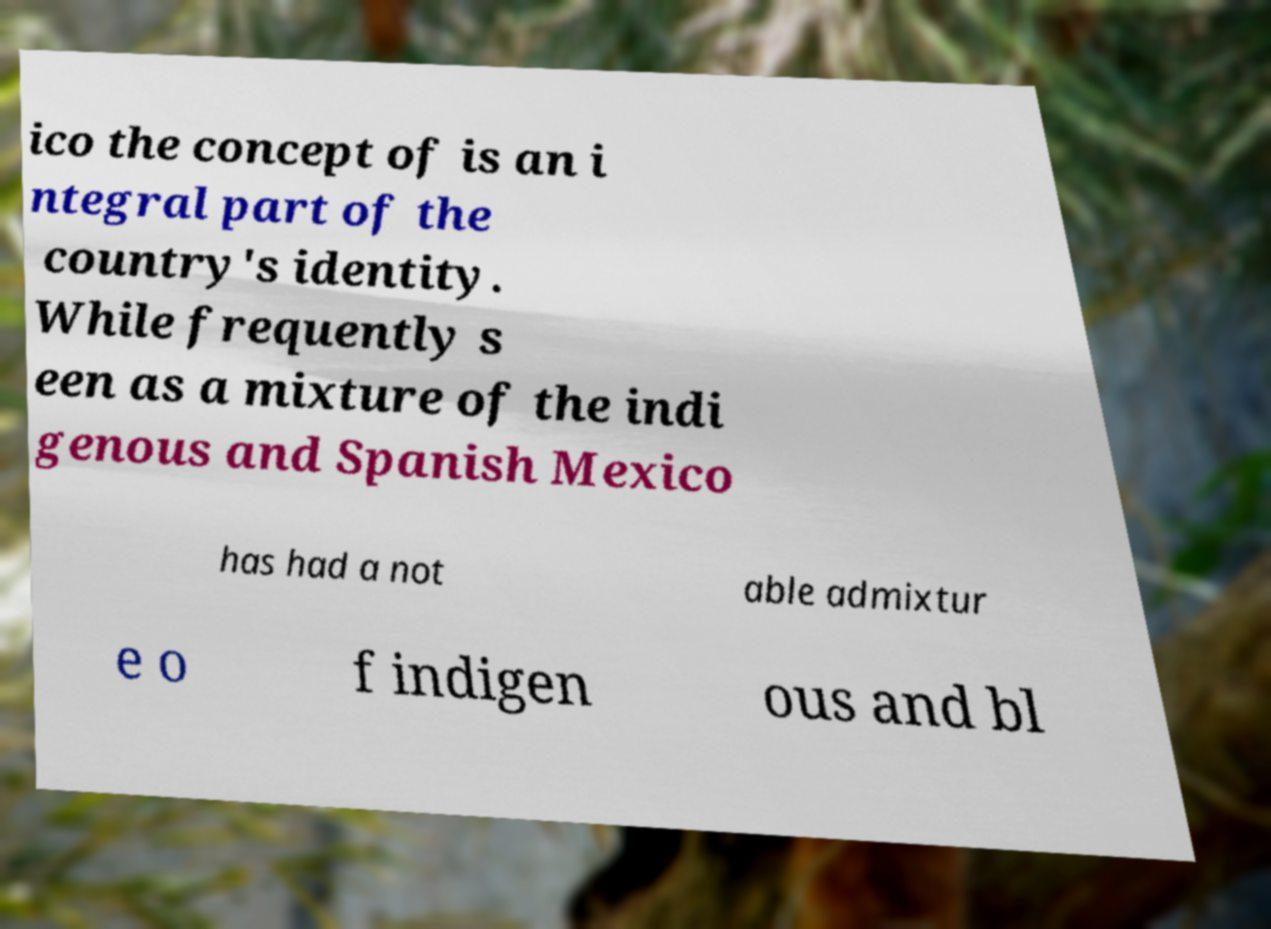Please read and relay the text visible in this image. What does it say? ico the concept of is an i ntegral part of the country's identity. While frequently s een as a mixture of the indi genous and Spanish Mexico has had a not able admixtur e o f indigen ous and bl 